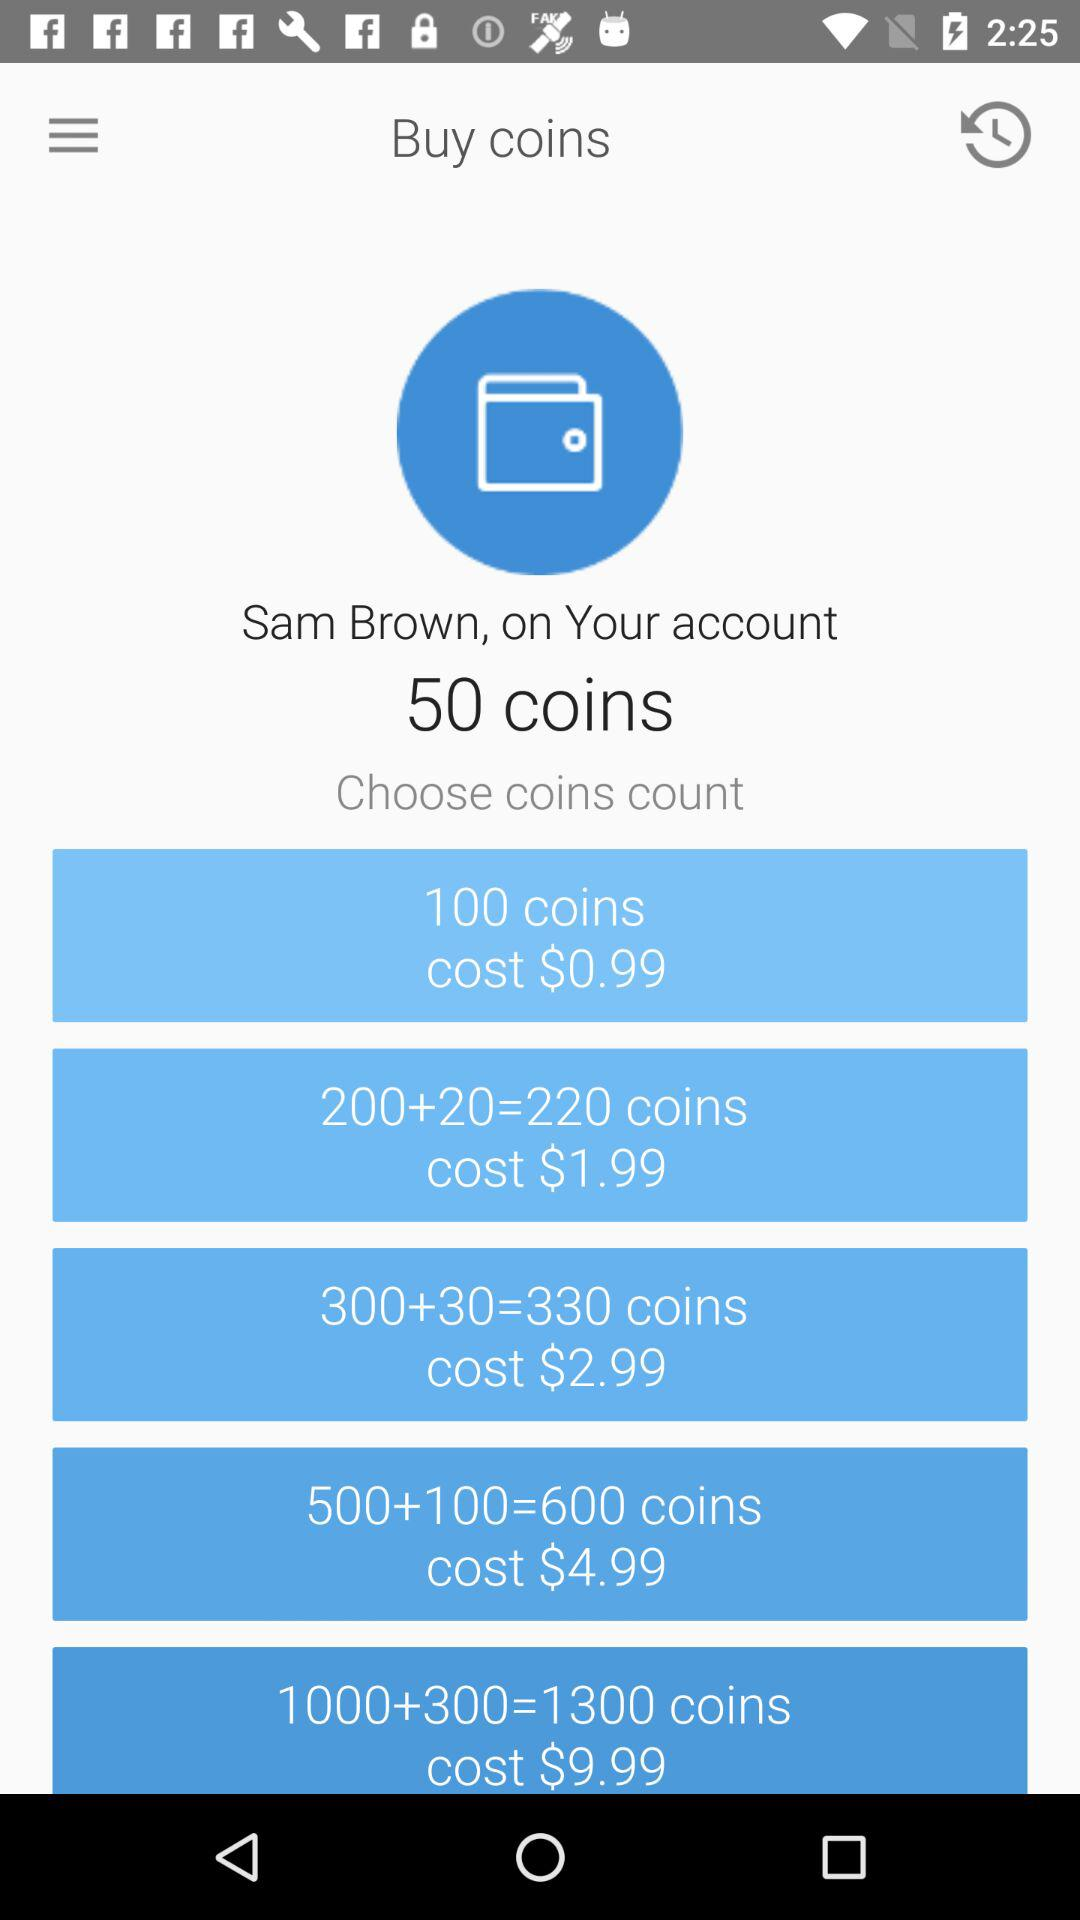How many coins will we get for the cost of $4.99? The coins you will get are 600. 